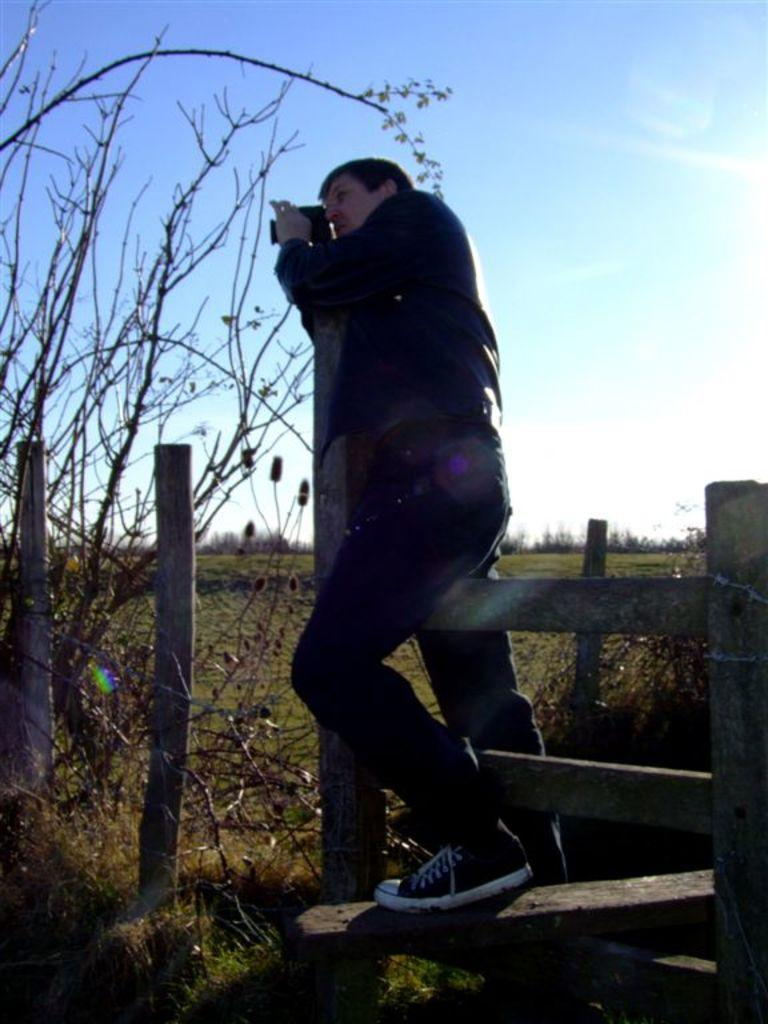What is the person in the image doing? There is a person standing on a wooden fence in the image. What can be seen in the background of the image? The sky is visible in the background of the image. What is located on the left side of the image? There is a tree on the left side of the image. Who else is present in the image? There is a person holding a camera in the image. What type of jam is being cooked in the oven in the image? There is no oven or jam present in the image. 